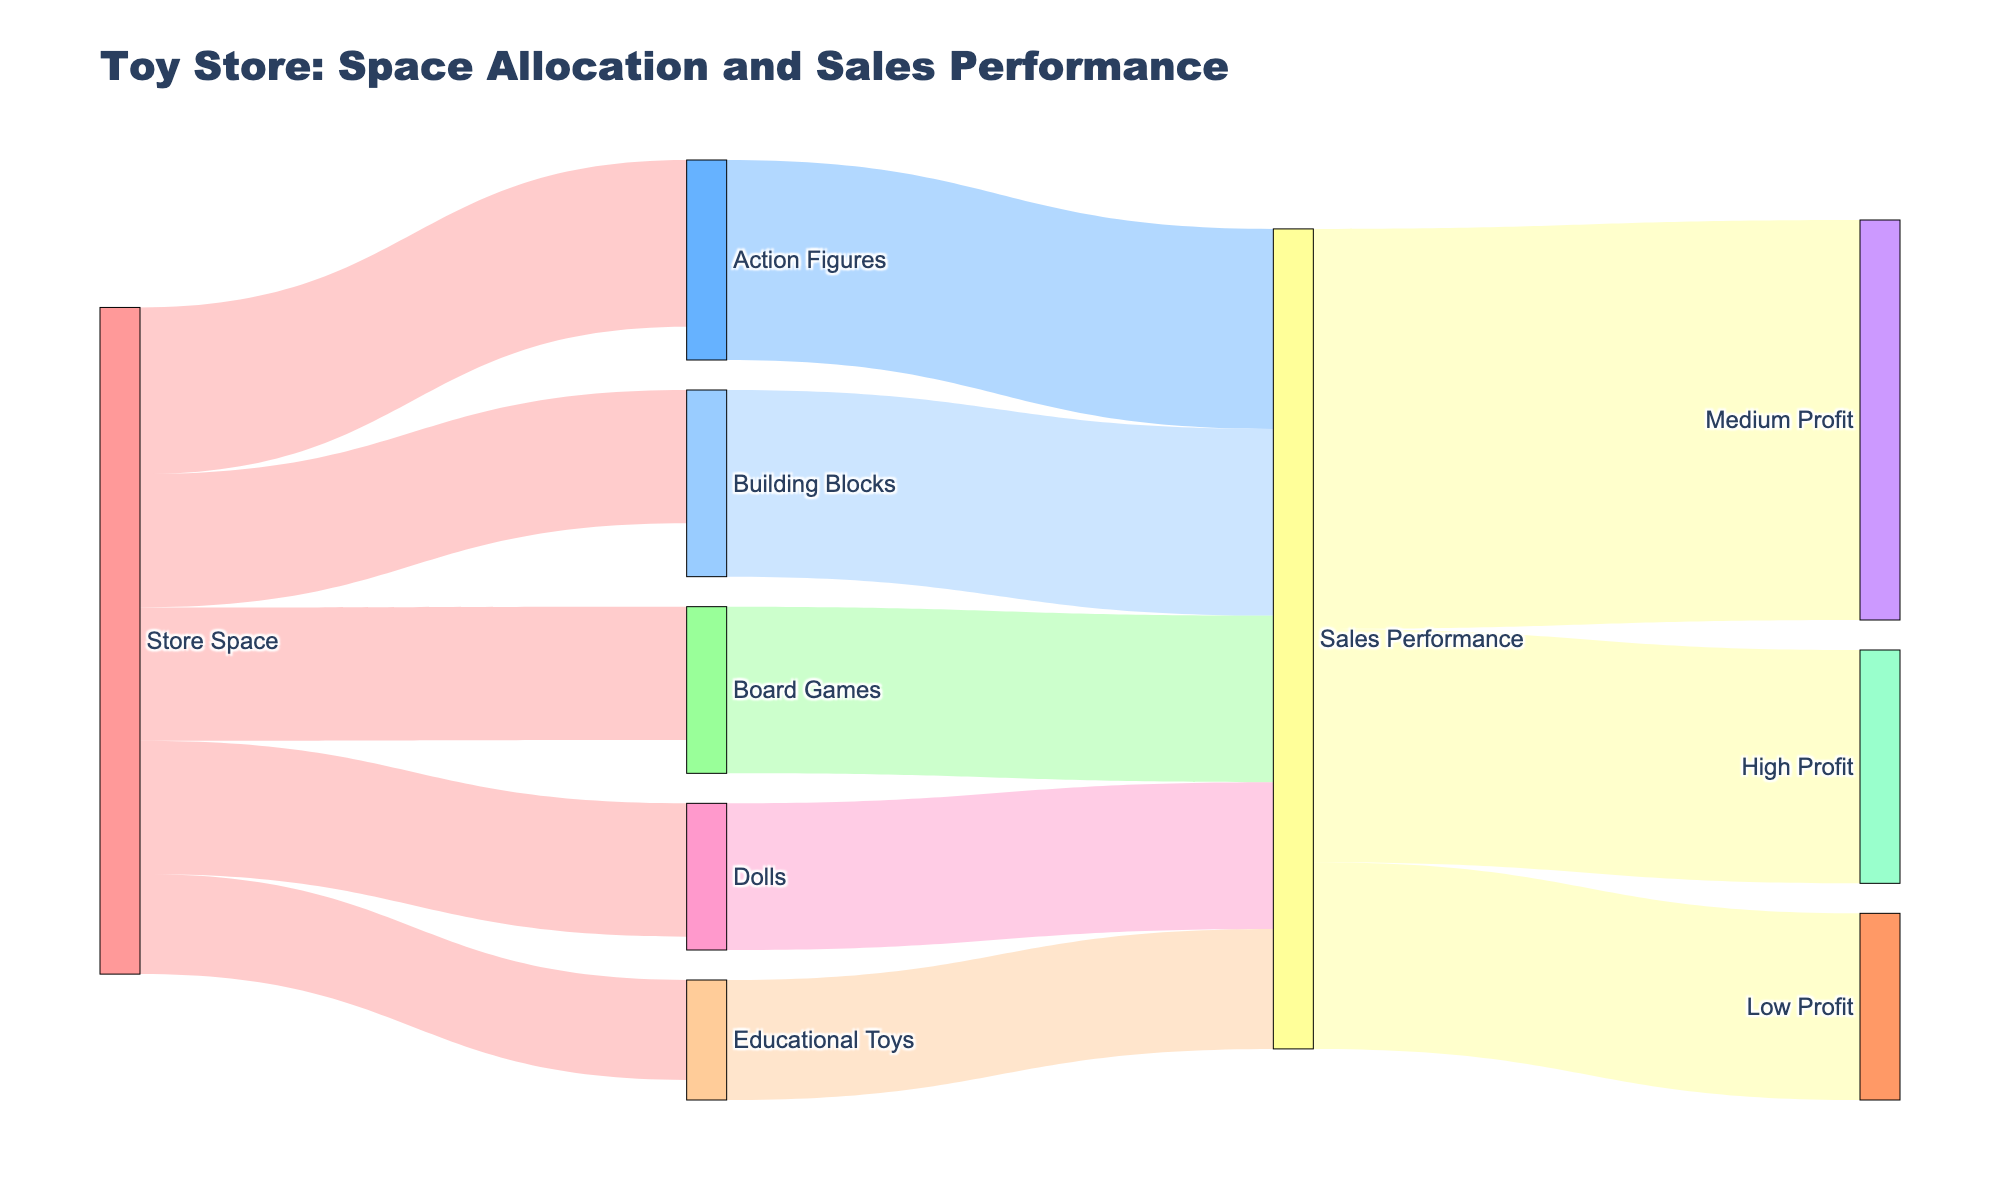What is the title of the figure? The title of the figure is located at the top and it provides an overview of what the diagram represents.
Answer: Toy Store: Space Allocation and Sales Performance Which toy category receives the most store space? To find this, look at the width of the arrows connected to "Store Space". The widest arrow points to "Action Figures".
Answer: Action Figures How much store space is allocated to Building Blocks? Observe the value labeled on the arrow that connects "Store Space" to "Building Blocks".
Answer: 20 Which toy category contributes the highest sales performance? Follow the arrows from each toy category to "Sales Performance". The arrow from "Action Figures" is the widest, indicating it has the highest sales performance.
Answer: Action Figures What is the total store space allocated to all toy categories? Sum the values of the arrows connecting "Store Space" to the toy categories: 25 (Action Figures) + 20 (Board Games) + 15 (Educational Toys) + 20 (Dolls) + 20 (Building Blocks).
Answer: 100 Which toy category has the lowest sales performance? Look for the thinnest arrow going from toy categories to "Sales Performance". The arrow from "Educational Toys" is the thinnest.
Answer: Educational Toys How many toy categories have their sales performance classified as Medium Profit? Follow the arrows going from "Sales Performance" to "Medium Profit". Count the number of arrows (each representing a toy category) that connect to "Medium Profit".
Answer: 5 Compare the sales performance of Dolls and Board Games. Which one is higher? Observe the width of the arrows connecting "Dolls" and "Board Games" to "Sales Performance". The arrow from "Board Games" is wider.
Answer: Board Games What portion of the sales performance leads to High Profit? Identify the value labeled on the arrow connecting "Sales Performance" to "High Profit". Divide it by the total value (sum of all profits) and multiply by 100 to get the percentage.
Answer: About 22% If Educational Toys' store space is increased to 20, how might that affect its sales performance given the current diagram trends? Use logical reasoning based on the trend that more store space correlates with higher sales performance. Increasing store space for Educational Toys to align with Building Blocks and Dolls might increase its sales performance closer to theirs.
Answer: Likely increase 